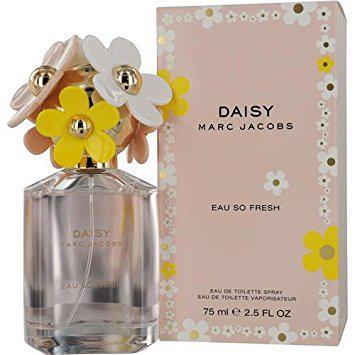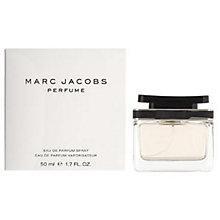The first image is the image on the left, the second image is the image on the right. Evaluate the accuracy of this statement regarding the images: "A perfume bottle in one image is topped with a decorative cap that is covered with plastic daisies.". Is it true? Answer yes or no. Yes. 